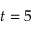<formula> <loc_0><loc_0><loc_500><loc_500>t = 5</formula> 